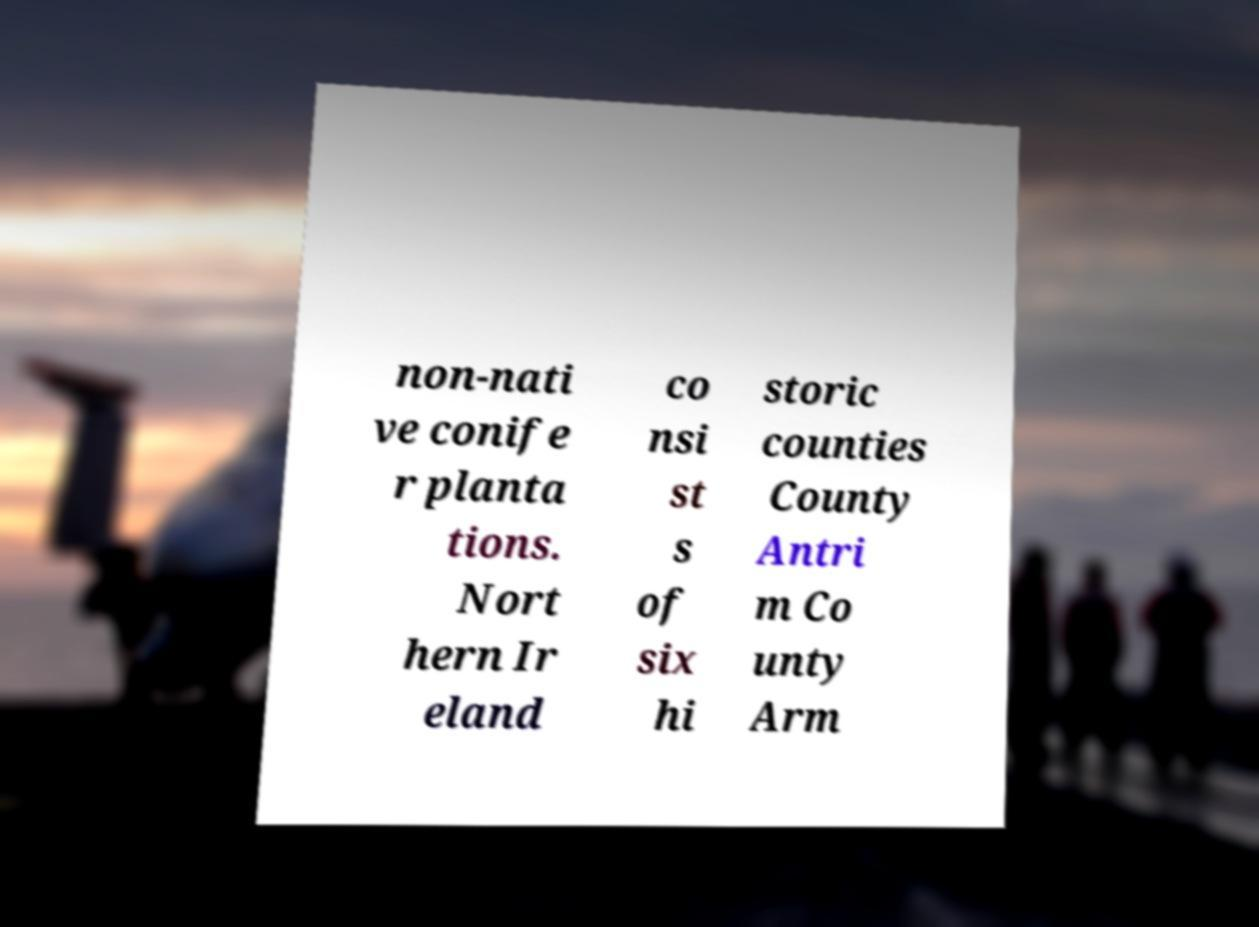Can you accurately transcribe the text from the provided image for me? non-nati ve conife r planta tions. Nort hern Ir eland co nsi st s of six hi storic counties County Antri m Co unty Arm 